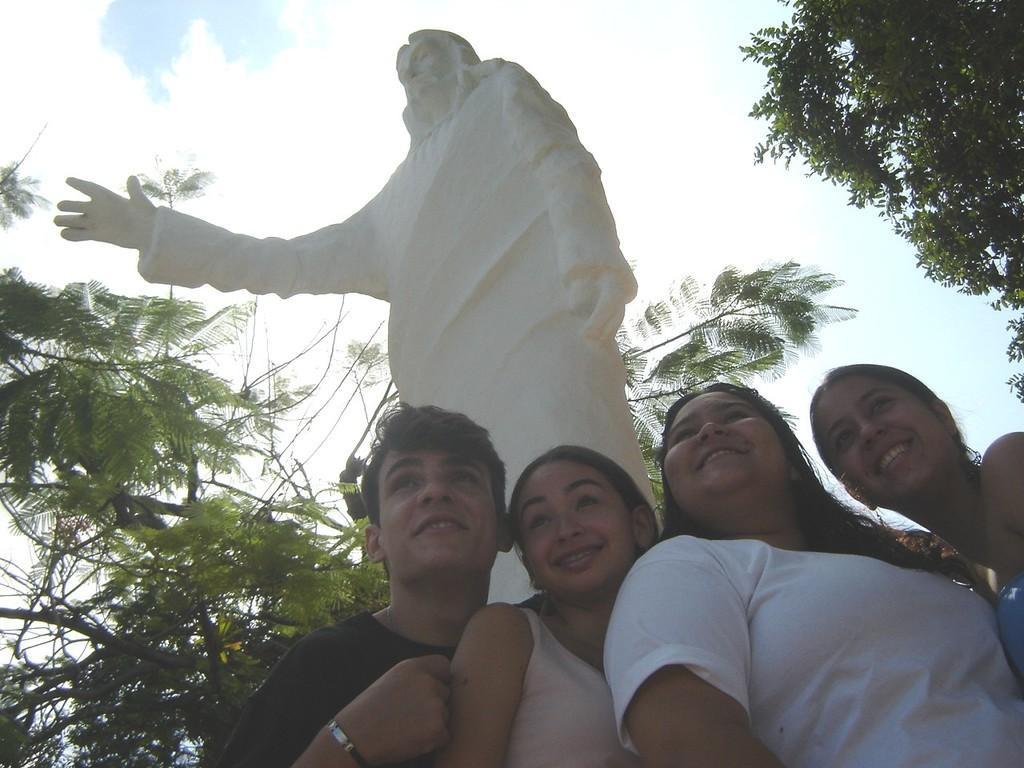How would you summarize this image in a sentence or two? In this image I can see three women and a man wearing black colored t shirt are standing. I can see few trees, a cream colored statue and in the background I can see the sky. 